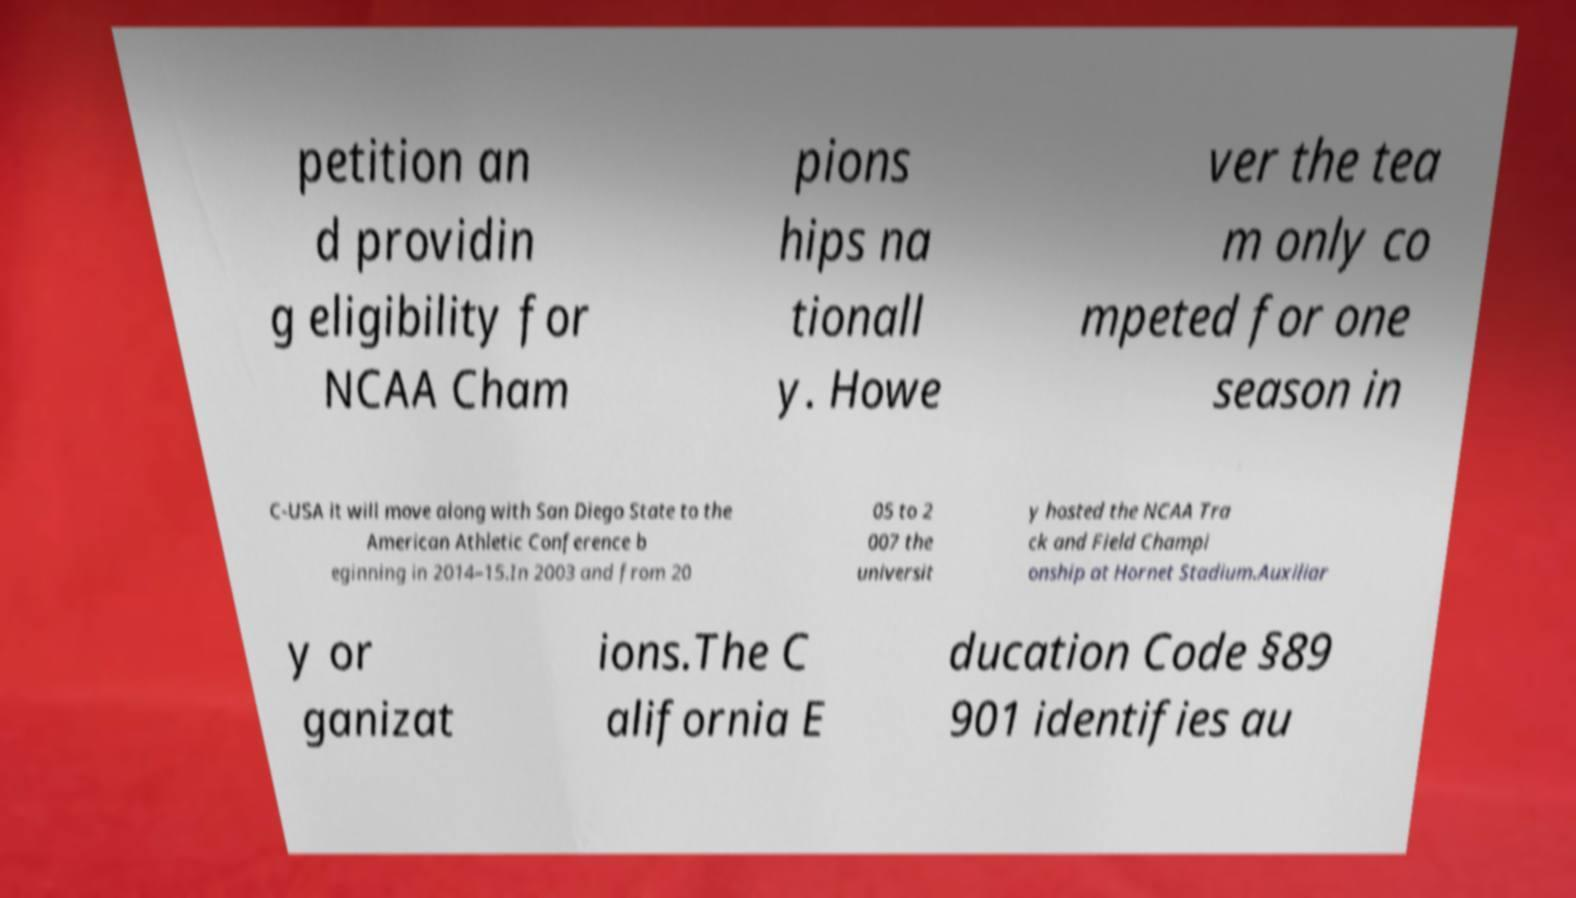There's text embedded in this image that I need extracted. Can you transcribe it verbatim? petition an d providin g eligibility for NCAA Cham pions hips na tionall y. Howe ver the tea m only co mpeted for one season in C-USA it will move along with San Diego State to the American Athletic Conference b eginning in 2014–15.In 2003 and from 20 05 to 2 007 the universit y hosted the NCAA Tra ck and Field Champi onship at Hornet Stadium.Auxiliar y or ganizat ions.The C alifornia E ducation Code §89 901 identifies au 